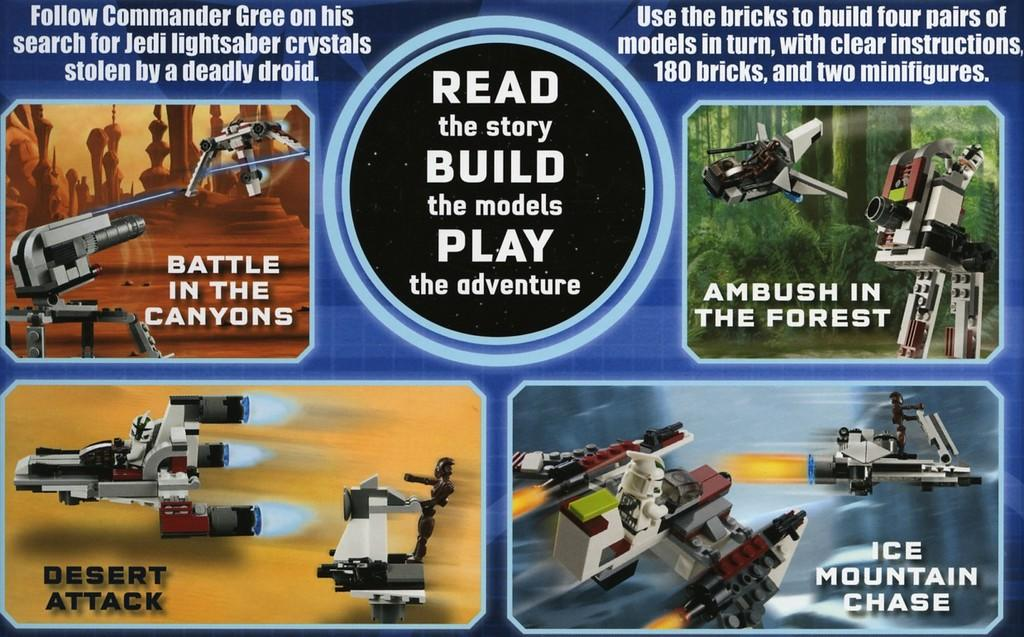<image>
Render a clear and concise summary of the photo. a poster that says Read the Story Build the Models 